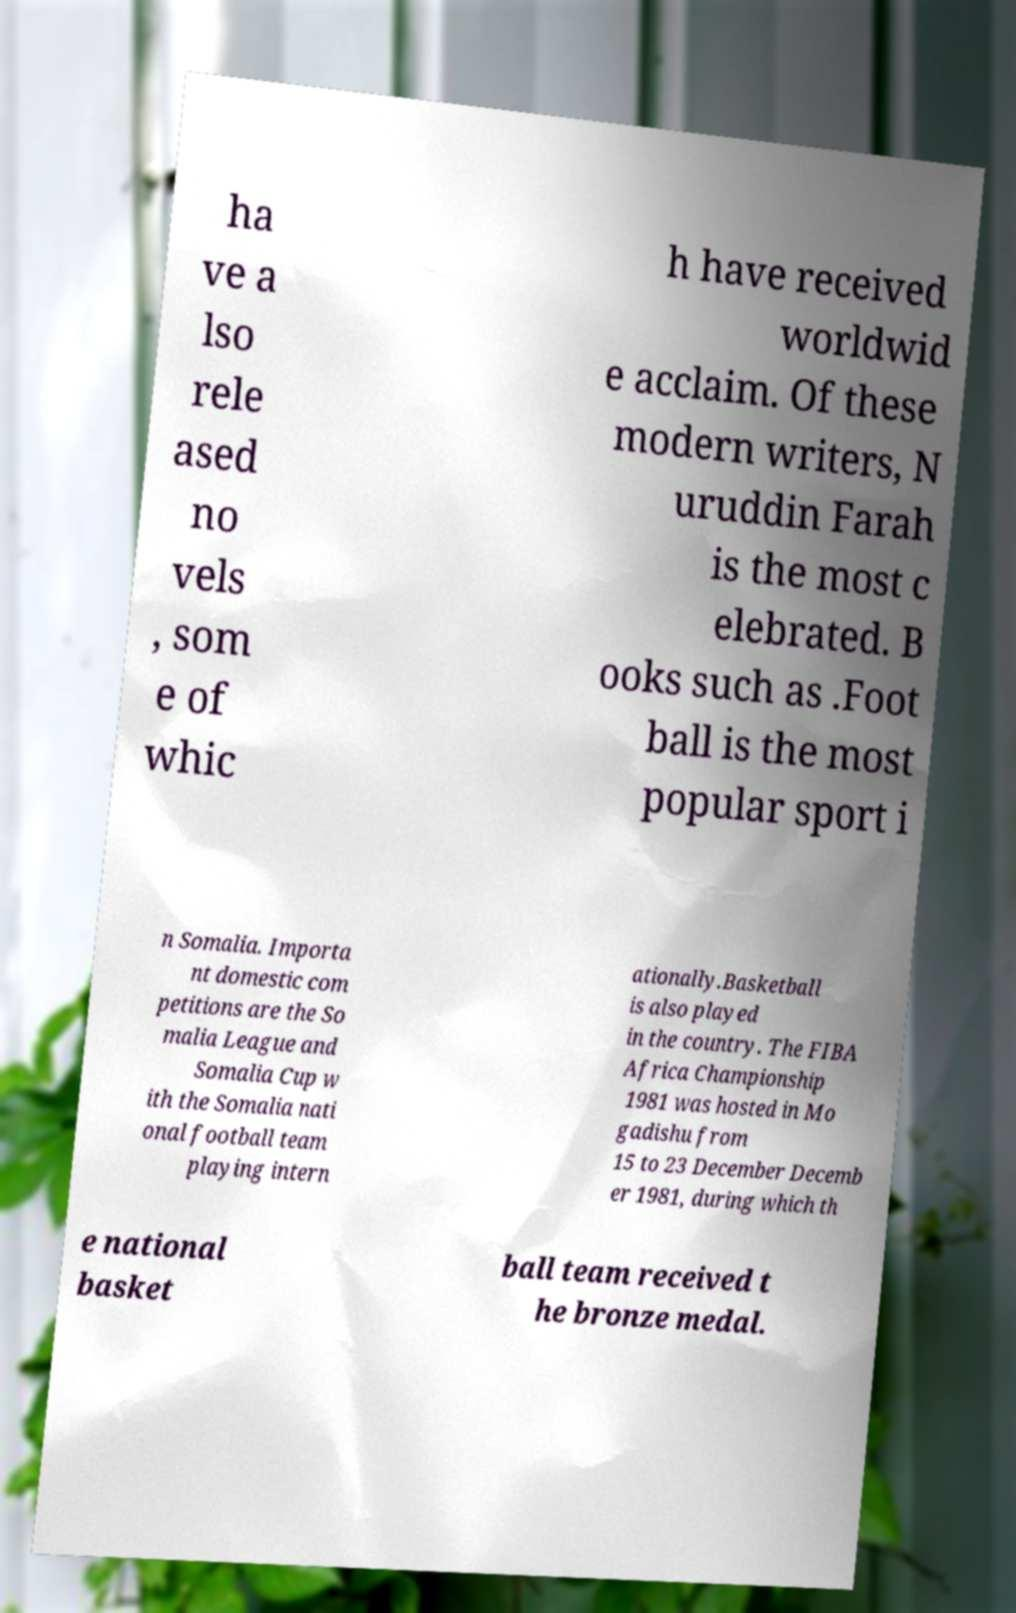Could you extract and type out the text from this image? ha ve a lso rele ased no vels , som e of whic h have received worldwid e acclaim. Of these modern writers, N uruddin Farah is the most c elebrated. B ooks such as .Foot ball is the most popular sport i n Somalia. Importa nt domestic com petitions are the So malia League and Somalia Cup w ith the Somalia nati onal football team playing intern ationally.Basketball is also played in the country. The FIBA Africa Championship 1981 was hosted in Mo gadishu from 15 to 23 December Decemb er 1981, during which th e national basket ball team received t he bronze medal. 